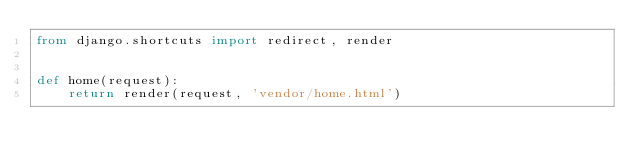<code> <loc_0><loc_0><loc_500><loc_500><_Python_>from django.shortcuts import redirect, render


def home(request):
    return render(request, 'vendor/home.html')</code> 